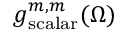Convert formula to latex. <formula><loc_0><loc_0><loc_500><loc_500>g _ { s c a l a r } ^ { m , m } ( \Omega )</formula> 